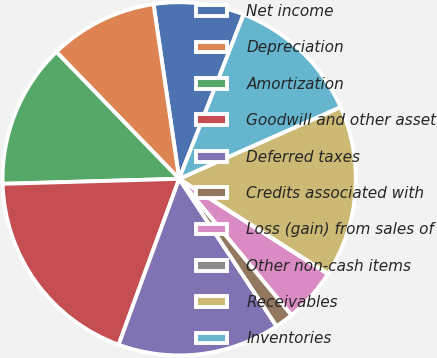<chart> <loc_0><loc_0><loc_500><loc_500><pie_chart><fcel>Net income<fcel>Depreciation<fcel>Amortization<fcel>Goodwill and other asset<fcel>Deferred taxes<fcel>Credits associated with<fcel>Loss (gain) from sales of<fcel>Other non-cash items<fcel>Receivables<fcel>Inventories<nl><fcel>8.27%<fcel>9.92%<fcel>13.21%<fcel>18.98%<fcel>14.86%<fcel>1.68%<fcel>4.97%<fcel>0.03%<fcel>15.69%<fcel>12.39%<nl></chart> 